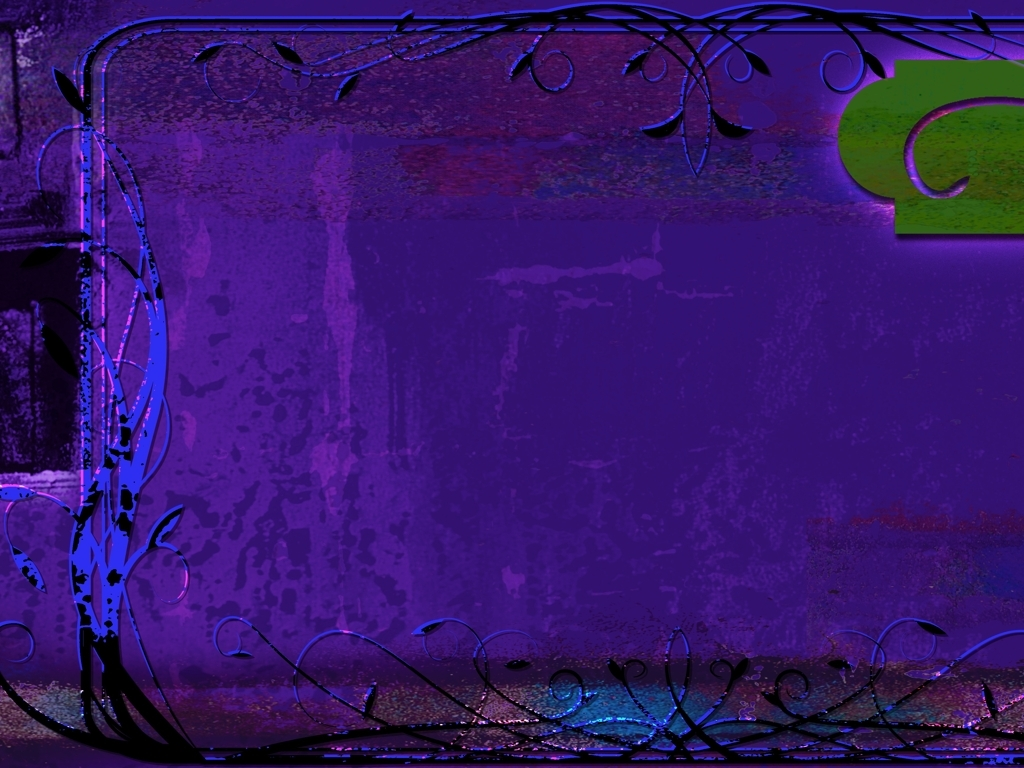This image has a very unique color palette; what emotions or atmosphere do you think it's trying to convey? The dominant use of purples and blues creates a mysterious and serene atmosphere, possibly evoking feelings of curiosity and calm. The image seems to be inviting viewers to let their imagination wander, suggesting an escape into a dreamlike or otherworldly place. 